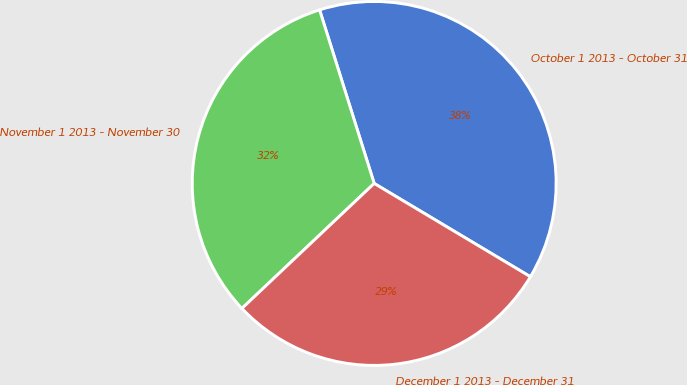<chart> <loc_0><loc_0><loc_500><loc_500><pie_chart><fcel>October 1 2013 - October 31<fcel>November 1 2013 - November 30<fcel>December 1 2013 - December 31<nl><fcel>38.42%<fcel>32.2%<fcel>29.38%<nl></chart> 